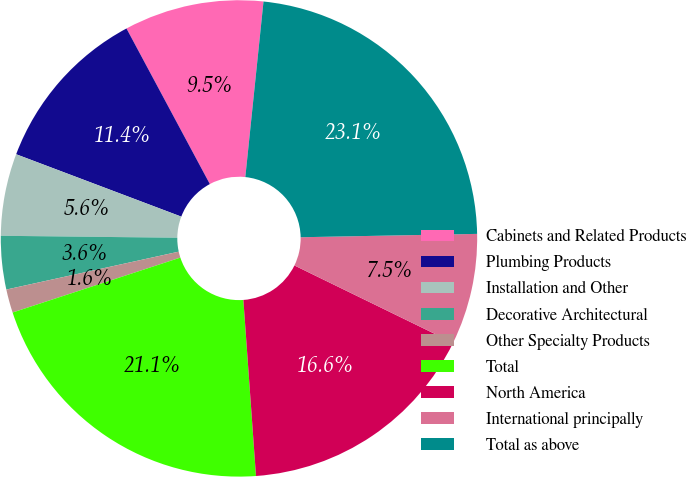<chart> <loc_0><loc_0><loc_500><loc_500><pie_chart><fcel>Cabinets and Related Products<fcel>Plumbing Products<fcel>Installation and Other<fcel>Decorative Architectural<fcel>Other Specialty Products<fcel>Total<fcel>North America<fcel>International principally<fcel>Total as above<nl><fcel>9.47%<fcel>11.42%<fcel>5.57%<fcel>3.62%<fcel>1.59%<fcel>21.1%<fcel>16.64%<fcel>7.52%<fcel>23.05%<nl></chart> 